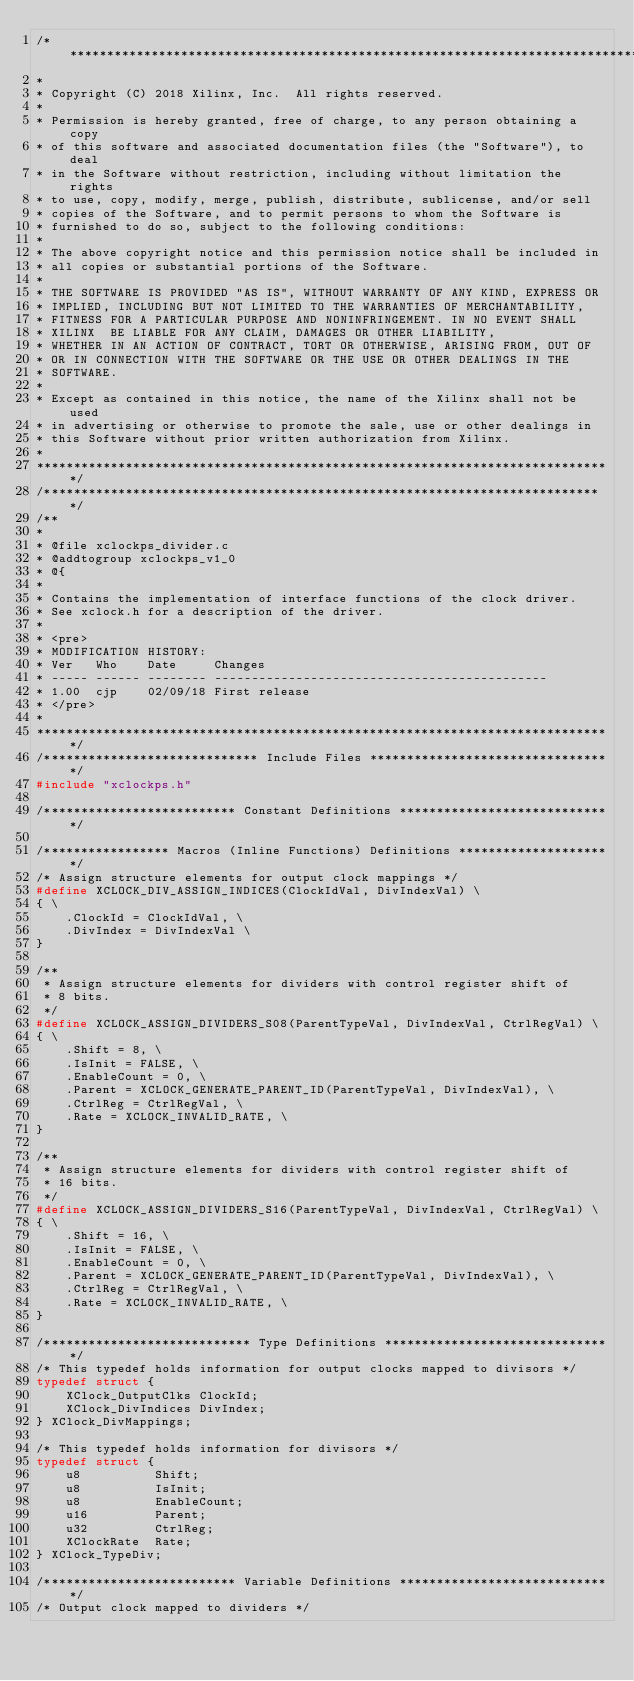Convert code to text. <code><loc_0><loc_0><loc_500><loc_500><_C_>/******************************************************************************
*
* Copyright (C) 2018 Xilinx, Inc.  All rights reserved.
*
* Permission is hereby granted, free of charge, to any person obtaining a copy
* of this software and associated documentation files (the "Software"), to deal
* in the Software without restriction, including without limitation the rights
* to use, copy, modify, merge, publish, distribute, sublicense, and/or sell
* copies of the Software, and to permit persons to whom the Software is
* furnished to do so, subject to the following conditions:
*
* The above copyright notice and this permission notice shall be included in
* all copies or substantial portions of the Software.
*
* THE SOFTWARE IS PROVIDED "AS IS", WITHOUT WARRANTY OF ANY KIND, EXPRESS OR
* IMPLIED, INCLUDING BUT NOT LIMITED TO THE WARRANTIES OF MERCHANTABILITY,
* FITNESS FOR A PARTICULAR PURPOSE AND NONINFRINGEMENT. IN NO EVENT SHALL
* XILINX  BE LIABLE FOR ANY CLAIM, DAMAGES OR OTHER LIABILITY,
* WHETHER IN AN ACTION OF CONTRACT, TORT OR OTHERWISE, ARISING FROM, OUT OF
* OR IN CONNECTION WITH THE SOFTWARE OR THE USE OR OTHER DEALINGS IN THE
* SOFTWARE.
*
* Except as contained in this notice, the name of the Xilinx shall not be used
* in advertising or otherwise to promote the sale, use or other dealings in
* this Software without prior written authorization from Xilinx.
*
******************************************************************************/
/****************************************************************************/
/**
*
* @file xclockps_divider.c
* @addtogroup xclockps_v1_0
* @{
*
* Contains the implementation of interface functions of the clock driver.
* See xclock.h for a description of the driver.
*
* <pre>
* MODIFICATION HISTORY:
* Ver   Who    Date     Changes
* ----- ------ -------- ---------------------------------------------
* 1.00  cjp    02/09/18 First release
* </pre>
*
******************************************************************************/
/***************************** Include Files *********************************/
#include "xclockps.h"

/************************** Constant Definitions *****************************/

/***************** Macros (Inline Functions) Definitions *********************/
/* Assign structure elements for output clock mappings */
#define XCLOCK_DIV_ASSIGN_INDICES(ClockIdVal, DivIndexVal) \
{ \
	.ClockId = ClockIdVal, \
	.DivIndex = DivIndexVal \
}

/**
 * Assign structure elements for dividers with control register shift of
 * 8 bits.
 */
#define XCLOCK_ASSIGN_DIVIDERS_S08(ParentTypeVal, DivIndexVal, CtrlRegVal) \
{ \
	.Shift = 8, \
	.IsInit = FALSE, \
	.EnableCount = 0, \
	.Parent = XCLOCK_GENERATE_PARENT_ID(ParentTypeVal, DivIndexVal), \
	.CtrlReg = CtrlRegVal, \
	.Rate = XCLOCK_INVALID_RATE, \
}

/**
 * Assign structure elements for dividers with control register shift of
 * 16 bits.
 */
#define XCLOCK_ASSIGN_DIVIDERS_S16(ParentTypeVal, DivIndexVal, CtrlRegVal) \
{ \
	.Shift = 16, \
	.IsInit = FALSE, \
	.EnableCount = 0, \
	.Parent = XCLOCK_GENERATE_PARENT_ID(ParentTypeVal, DivIndexVal), \
	.CtrlReg = CtrlRegVal, \
	.Rate = XCLOCK_INVALID_RATE, \
}

/**************************** Type Definitions *******************************/
/* This typedef holds information for output clocks mapped to divisors */
typedef struct {
	XClock_OutputClks ClockId;
	XClock_DivIndices DivIndex;
} XClock_DivMappings;

/* This typedef holds information for divisors */
typedef struct {
	u8          Shift;
	u8          IsInit;
	u8          EnableCount;
	u16         Parent;
	u32         CtrlReg;
	XClockRate  Rate;
} XClock_TypeDiv;

/************************** Variable Definitions *****************************/
/* Output clock mapped to dividers */</code> 